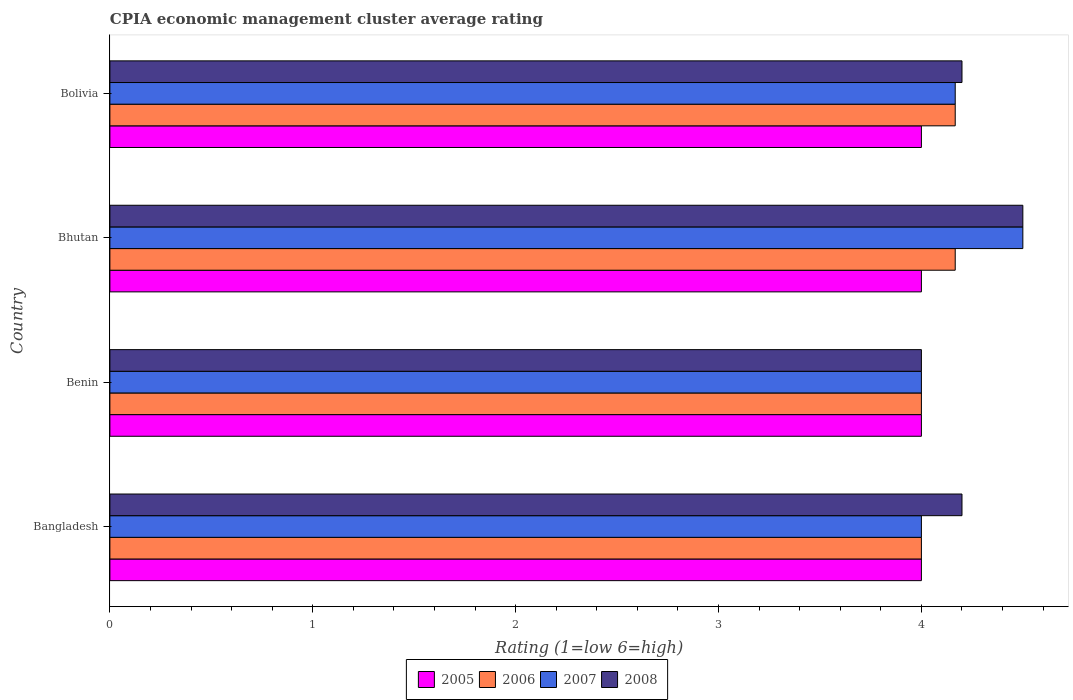How many different coloured bars are there?
Keep it short and to the point. 4. Are the number of bars on each tick of the Y-axis equal?
Your response must be concise. Yes. How many bars are there on the 3rd tick from the top?
Your answer should be very brief. 4. What is the label of the 2nd group of bars from the top?
Your answer should be compact. Bhutan. In which country was the CPIA rating in 2006 maximum?
Provide a succinct answer. Bhutan. In which country was the CPIA rating in 2007 minimum?
Offer a very short reply. Bangladesh. What is the difference between the CPIA rating in 2006 in Bolivia and the CPIA rating in 2008 in Bangladesh?
Provide a succinct answer. -0.03. What is the average CPIA rating in 2005 per country?
Provide a succinct answer. 4. What is the difference between the CPIA rating in 2008 and CPIA rating in 2005 in Benin?
Give a very brief answer. 0. In how many countries, is the CPIA rating in 2005 greater than 4 ?
Give a very brief answer. 0. What is the ratio of the CPIA rating in 2005 in Benin to that in Bolivia?
Ensure brevity in your answer.  1. What is the difference between the highest and the second highest CPIA rating in 2006?
Give a very brief answer. 0. What is the difference between the highest and the lowest CPIA rating in 2005?
Ensure brevity in your answer.  0. In how many countries, is the CPIA rating in 2005 greater than the average CPIA rating in 2005 taken over all countries?
Offer a terse response. 0. Is the sum of the CPIA rating in 2007 in Benin and Bolivia greater than the maximum CPIA rating in 2008 across all countries?
Provide a succinct answer. Yes. Is it the case that in every country, the sum of the CPIA rating in 2008 and CPIA rating in 2005 is greater than the sum of CPIA rating in 2007 and CPIA rating in 2006?
Your response must be concise. No. How many bars are there?
Your answer should be very brief. 16. Are all the bars in the graph horizontal?
Your response must be concise. Yes. How many countries are there in the graph?
Offer a terse response. 4. What is the difference between two consecutive major ticks on the X-axis?
Your response must be concise. 1. Where does the legend appear in the graph?
Offer a terse response. Bottom center. How are the legend labels stacked?
Your answer should be very brief. Horizontal. What is the title of the graph?
Give a very brief answer. CPIA economic management cluster average rating. Does "2012" appear as one of the legend labels in the graph?
Your answer should be very brief. No. What is the label or title of the X-axis?
Ensure brevity in your answer.  Rating (1=low 6=high). What is the Rating (1=low 6=high) in 2007 in Bangladesh?
Your response must be concise. 4. What is the Rating (1=low 6=high) of 2006 in Benin?
Ensure brevity in your answer.  4. What is the Rating (1=low 6=high) of 2005 in Bhutan?
Provide a short and direct response. 4. What is the Rating (1=low 6=high) in 2006 in Bhutan?
Your response must be concise. 4.17. What is the Rating (1=low 6=high) of 2008 in Bhutan?
Your response must be concise. 4.5. What is the Rating (1=low 6=high) in 2006 in Bolivia?
Your answer should be compact. 4.17. What is the Rating (1=low 6=high) in 2007 in Bolivia?
Offer a very short reply. 4.17. What is the Rating (1=low 6=high) in 2008 in Bolivia?
Ensure brevity in your answer.  4.2. Across all countries, what is the maximum Rating (1=low 6=high) in 2006?
Offer a very short reply. 4.17. Across all countries, what is the minimum Rating (1=low 6=high) of 2005?
Offer a very short reply. 4. Across all countries, what is the minimum Rating (1=low 6=high) of 2006?
Keep it short and to the point. 4. Across all countries, what is the minimum Rating (1=low 6=high) of 2007?
Your answer should be very brief. 4. Across all countries, what is the minimum Rating (1=low 6=high) in 2008?
Offer a terse response. 4. What is the total Rating (1=low 6=high) of 2006 in the graph?
Offer a terse response. 16.33. What is the total Rating (1=low 6=high) in 2007 in the graph?
Your answer should be compact. 16.67. What is the difference between the Rating (1=low 6=high) in 2006 in Bangladesh and that in Benin?
Make the answer very short. 0. What is the difference between the Rating (1=low 6=high) in 2005 in Bangladesh and that in Bhutan?
Make the answer very short. 0. What is the difference between the Rating (1=low 6=high) in 2005 in Bangladesh and that in Bolivia?
Your answer should be very brief. 0. What is the difference between the Rating (1=low 6=high) of 2006 in Bangladesh and that in Bolivia?
Offer a terse response. -0.17. What is the difference between the Rating (1=low 6=high) in 2007 in Bangladesh and that in Bolivia?
Ensure brevity in your answer.  -0.17. What is the difference between the Rating (1=low 6=high) of 2008 in Bangladesh and that in Bolivia?
Your answer should be compact. 0. What is the difference between the Rating (1=low 6=high) of 2005 in Benin and that in Bhutan?
Your answer should be very brief. 0. What is the difference between the Rating (1=low 6=high) in 2007 in Benin and that in Bhutan?
Your answer should be compact. -0.5. What is the difference between the Rating (1=low 6=high) in 2008 in Benin and that in Bhutan?
Provide a succinct answer. -0.5. What is the difference between the Rating (1=low 6=high) of 2006 in Benin and that in Bolivia?
Offer a terse response. -0.17. What is the difference between the Rating (1=low 6=high) of 2007 in Benin and that in Bolivia?
Keep it short and to the point. -0.17. What is the difference between the Rating (1=low 6=high) in 2008 in Benin and that in Bolivia?
Make the answer very short. -0.2. What is the difference between the Rating (1=low 6=high) in 2006 in Bhutan and that in Bolivia?
Keep it short and to the point. 0. What is the difference between the Rating (1=low 6=high) of 2007 in Bhutan and that in Bolivia?
Offer a very short reply. 0.33. What is the difference between the Rating (1=low 6=high) of 2005 in Bangladesh and the Rating (1=low 6=high) of 2006 in Benin?
Your response must be concise. 0. What is the difference between the Rating (1=low 6=high) of 2006 in Bangladesh and the Rating (1=low 6=high) of 2008 in Benin?
Make the answer very short. 0. What is the difference between the Rating (1=low 6=high) in 2005 in Bangladesh and the Rating (1=low 6=high) in 2006 in Bhutan?
Offer a terse response. -0.17. What is the difference between the Rating (1=low 6=high) of 2005 in Bangladesh and the Rating (1=low 6=high) of 2007 in Bhutan?
Give a very brief answer. -0.5. What is the difference between the Rating (1=low 6=high) of 2007 in Bangladesh and the Rating (1=low 6=high) of 2008 in Bhutan?
Offer a very short reply. -0.5. What is the difference between the Rating (1=low 6=high) in 2007 in Bangladesh and the Rating (1=low 6=high) in 2008 in Bolivia?
Give a very brief answer. -0.2. What is the difference between the Rating (1=low 6=high) in 2005 in Benin and the Rating (1=low 6=high) in 2006 in Bhutan?
Your answer should be compact. -0.17. What is the difference between the Rating (1=low 6=high) in 2006 in Benin and the Rating (1=low 6=high) in 2007 in Bhutan?
Provide a succinct answer. -0.5. What is the difference between the Rating (1=low 6=high) in 2005 in Benin and the Rating (1=low 6=high) in 2007 in Bolivia?
Keep it short and to the point. -0.17. What is the difference between the Rating (1=low 6=high) in 2005 in Benin and the Rating (1=low 6=high) in 2008 in Bolivia?
Ensure brevity in your answer.  -0.2. What is the difference between the Rating (1=low 6=high) in 2006 in Benin and the Rating (1=low 6=high) in 2008 in Bolivia?
Provide a succinct answer. -0.2. What is the difference between the Rating (1=low 6=high) of 2007 in Benin and the Rating (1=low 6=high) of 2008 in Bolivia?
Ensure brevity in your answer.  -0.2. What is the difference between the Rating (1=low 6=high) in 2005 in Bhutan and the Rating (1=low 6=high) in 2006 in Bolivia?
Give a very brief answer. -0.17. What is the difference between the Rating (1=low 6=high) of 2005 in Bhutan and the Rating (1=low 6=high) of 2007 in Bolivia?
Offer a very short reply. -0.17. What is the difference between the Rating (1=low 6=high) in 2006 in Bhutan and the Rating (1=low 6=high) in 2008 in Bolivia?
Keep it short and to the point. -0.03. What is the average Rating (1=low 6=high) in 2005 per country?
Offer a terse response. 4. What is the average Rating (1=low 6=high) of 2006 per country?
Your response must be concise. 4.08. What is the average Rating (1=low 6=high) in 2007 per country?
Keep it short and to the point. 4.17. What is the average Rating (1=low 6=high) in 2008 per country?
Give a very brief answer. 4.22. What is the difference between the Rating (1=low 6=high) of 2005 and Rating (1=low 6=high) of 2008 in Bangladesh?
Give a very brief answer. -0.2. What is the difference between the Rating (1=low 6=high) in 2006 and Rating (1=low 6=high) in 2008 in Bangladesh?
Ensure brevity in your answer.  -0.2. What is the difference between the Rating (1=low 6=high) in 2005 and Rating (1=low 6=high) in 2006 in Benin?
Give a very brief answer. 0. What is the difference between the Rating (1=low 6=high) in 2005 and Rating (1=low 6=high) in 2007 in Benin?
Provide a succinct answer. 0. What is the difference between the Rating (1=low 6=high) of 2007 and Rating (1=low 6=high) of 2008 in Benin?
Provide a succinct answer. 0. What is the difference between the Rating (1=low 6=high) of 2005 and Rating (1=low 6=high) of 2006 in Bhutan?
Make the answer very short. -0.17. What is the difference between the Rating (1=low 6=high) in 2005 and Rating (1=low 6=high) in 2007 in Bhutan?
Your response must be concise. -0.5. What is the difference between the Rating (1=low 6=high) of 2006 and Rating (1=low 6=high) of 2008 in Bhutan?
Provide a short and direct response. -0.33. What is the difference between the Rating (1=low 6=high) in 2005 and Rating (1=low 6=high) in 2006 in Bolivia?
Provide a succinct answer. -0.17. What is the difference between the Rating (1=low 6=high) of 2006 and Rating (1=low 6=high) of 2008 in Bolivia?
Your answer should be very brief. -0.03. What is the difference between the Rating (1=low 6=high) in 2007 and Rating (1=low 6=high) in 2008 in Bolivia?
Your answer should be very brief. -0.03. What is the ratio of the Rating (1=low 6=high) in 2006 in Bangladesh to that in Benin?
Provide a short and direct response. 1. What is the ratio of the Rating (1=low 6=high) of 2007 in Bangladesh to that in Benin?
Make the answer very short. 1. What is the ratio of the Rating (1=low 6=high) of 2008 in Bangladesh to that in Benin?
Provide a succinct answer. 1.05. What is the ratio of the Rating (1=low 6=high) in 2005 in Bangladesh to that in Bhutan?
Provide a short and direct response. 1. What is the ratio of the Rating (1=low 6=high) in 2008 in Bangladesh to that in Bolivia?
Ensure brevity in your answer.  1. What is the ratio of the Rating (1=low 6=high) in 2005 in Benin to that in Bhutan?
Provide a short and direct response. 1. What is the ratio of the Rating (1=low 6=high) of 2006 in Benin to that in Bhutan?
Offer a very short reply. 0.96. What is the ratio of the Rating (1=low 6=high) in 2007 in Benin to that in Bhutan?
Offer a terse response. 0.89. What is the ratio of the Rating (1=low 6=high) of 2005 in Bhutan to that in Bolivia?
Give a very brief answer. 1. What is the ratio of the Rating (1=low 6=high) of 2006 in Bhutan to that in Bolivia?
Your response must be concise. 1. What is the ratio of the Rating (1=low 6=high) in 2007 in Bhutan to that in Bolivia?
Make the answer very short. 1.08. What is the ratio of the Rating (1=low 6=high) of 2008 in Bhutan to that in Bolivia?
Your answer should be very brief. 1.07. What is the difference between the highest and the second highest Rating (1=low 6=high) in 2005?
Your answer should be very brief. 0. What is the difference between the highest and the lowest Rating (1=low 6=high) in 2005?
Provide a short and direct response. 0. What is the difference between the highest and the lowest Rating (1=low 6=high) of 2006?
Your answer should be compact. 0.17. 